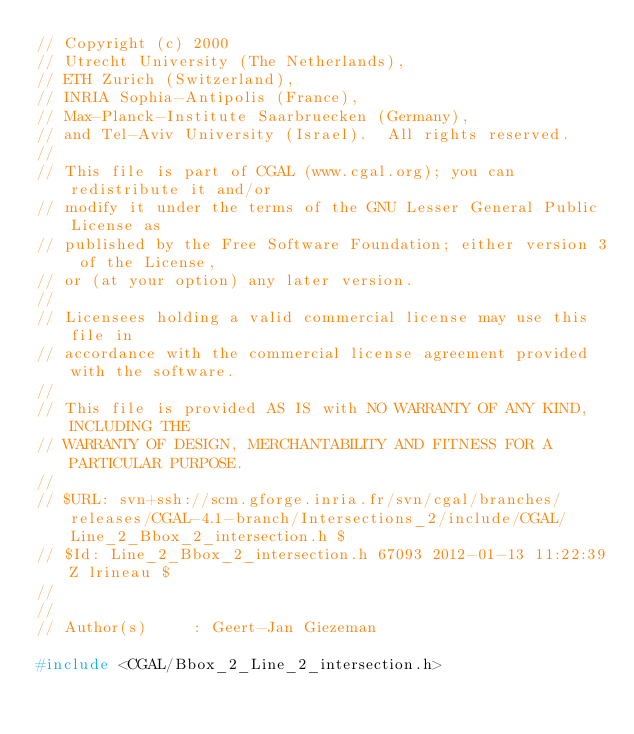Convert code to text. <code><loc_0><loc_0><loc_500><loc_500><_C_>// Copyright (c) 2000  
// Utrecht University (The Netherlands),
// ETH Zurich (Switzerland),
// INRIA Sophia-Antipolis (France),
// Max-Planck-Institute Saarbruecken (Germany),
// and Tel-Aviv University (Israel).  All rights reserved. 
//
// This file is part of CGAL (www.cgal.org); you can redistribute it and/or
// modify it under the terms of the GNU Lesser General Public License as
// published by the Free Software Foundation; either version 3 of the License,
// or (at your option) any later version.
//
// Licensees holding a valid commercial license may use this file in
// accordance with the commercial license agreement provided with the software.
//
// This file is provided AS IS with NO WARRANTY OF ANY KIND, INCLUDING THE
// WARRANTY OF DESIGN, MERCHANTABILITY AND FITNESS FOR A PARTICULAR PURPOSE.
//
// $URL: svn+ssh://scm.gforge.inria.fr/svn/cgal/branches/releases/CGAL-4.1-branch/Intersections_2/include/CGAL/Line_2_Bbox_2_intersection.h $
// $Id: Line_2_Bbox_2_intersection.h 67093 2012-01-13 11:22:39Z lrineau $
// 
//
// Author(s)     : Geert-Jan Giezeman

#include <CGAL/Bbox_2_Line_2_intersection.h>
</code> 